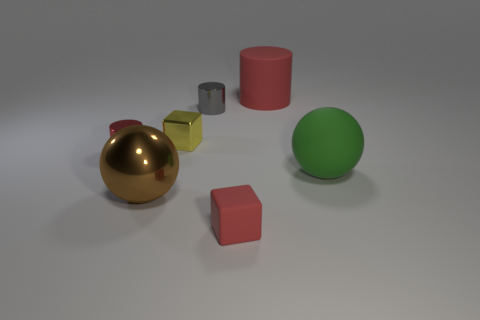Add 1 cyan metallic cylinders. How many objects exist? 8 Subtract all cubes. How many objects are left? 5 Subtract all yellow blocks. How many blocks are left? 1 Subtract all small shiny cylinders. How many cylinders are left? 1 Subtract 2 balls. How many balls are left? 0 Subtract 1 gray cylinders. How many objects are left? 6 Subtract all cyan balls. Subtract all brown blocks. How many balls are left? 2 Subtract all purple cylinders. How many red blocks are left? 1 Subtract all cyan metal spheres. Subtract all big matte spheres. How many objects are left? 6 Add 6 red metallic things. How many red metallic things are left? 7 